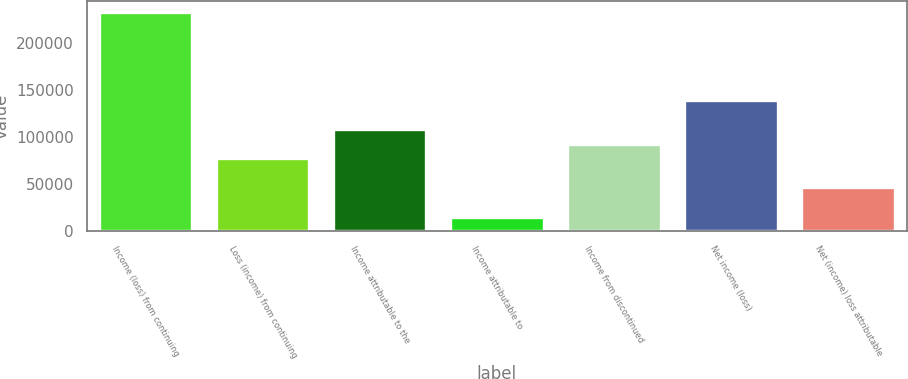<chart> <loc_0><loc_0><loc_500><loc_500><bar_chart><fcel>Income (loss) from continuing<fcel>Loss (income) from continuing<fcel>Income attributable to the<fcel>Income attributable to<fcel>Income from discontinued<fcel>Net income (loss)<fcel>Net (income) loss attributable<nl><fcel>232810<fcel>77603.8<fcel>108645<fcel>15521.3<fcel>93124.5<fcel>139686<fcel>46562.6<nl></chart> 